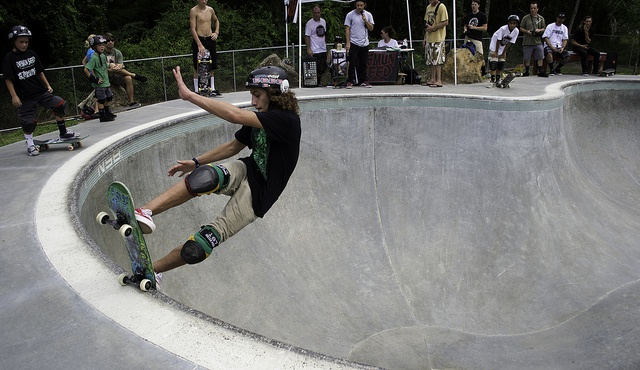Describe the objects in this image and their specific colors. I can see people in black, gray, and darkgray tones, people in black, gray, darkgray, and maroon tones, skateboard in black, gray, darkgreen, and darkgray tones, people in black, gray, and tan tones, and people in black, gray, and tan tones in this image. 